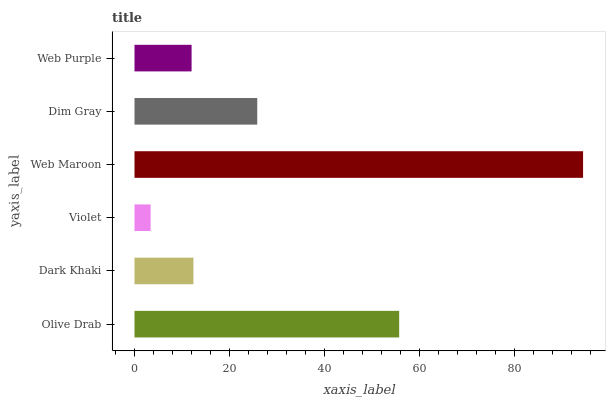Is Violet the minimum?
Answer yes or no. Yes. Is Web Maroon the maximum?
Answer yes or no. Yes. Is Dark Khaki the minimum?
Answer yes or no. No. Is Dark Khaki the maximum?
Answer yes or no. No. Is Olive Drab greater than Dark Khaki?
Answer yes or no. Yes. Is Dark Khaki less than Olive Drab?
Answer yes or no. Yes. Is Dark Khaki greater than Olive Drab?
Answer yes or no. No. Is Olive Drab less than Dark Khaki?
Answer yes or no. No. Is Dim Gray the high median?
Answer yes or no. Yes. Is Dark Khaki the low median?
Answer yes or no. Yes. Is Olive Drab the high median?
Answer yes or no. No. Is Violet the low median?
Answer yes or no. No. 